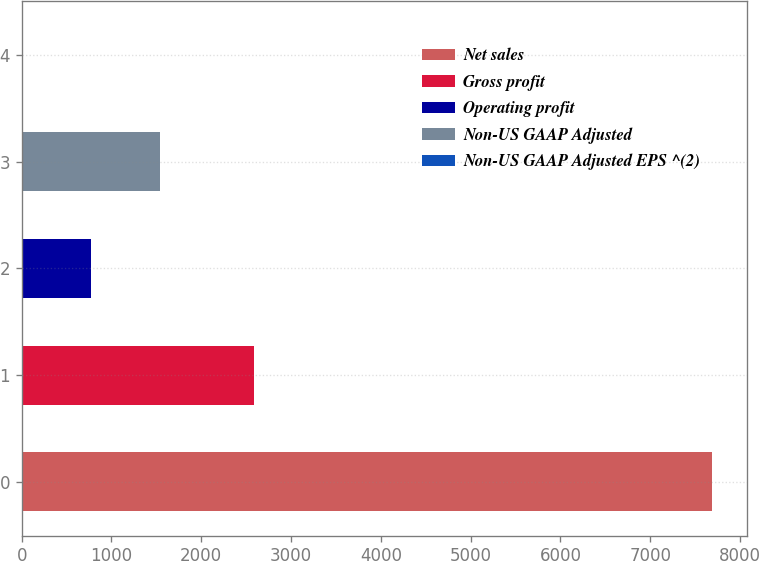<chart> <loc_0><loc_0><loc_500><loc_500><bar_chart><fcel>Net sales<fcel>Gross profit<fcel>Operating profit<fcel>Non-US GAAP Adjusted<fcel>Non-US GAAP Adjusted EPS ^(2)<nl><fcel>7690.8<fcel>2589.9<fcel>770.33<fcel>1539.27<fcel>1.39<nl></chart> 